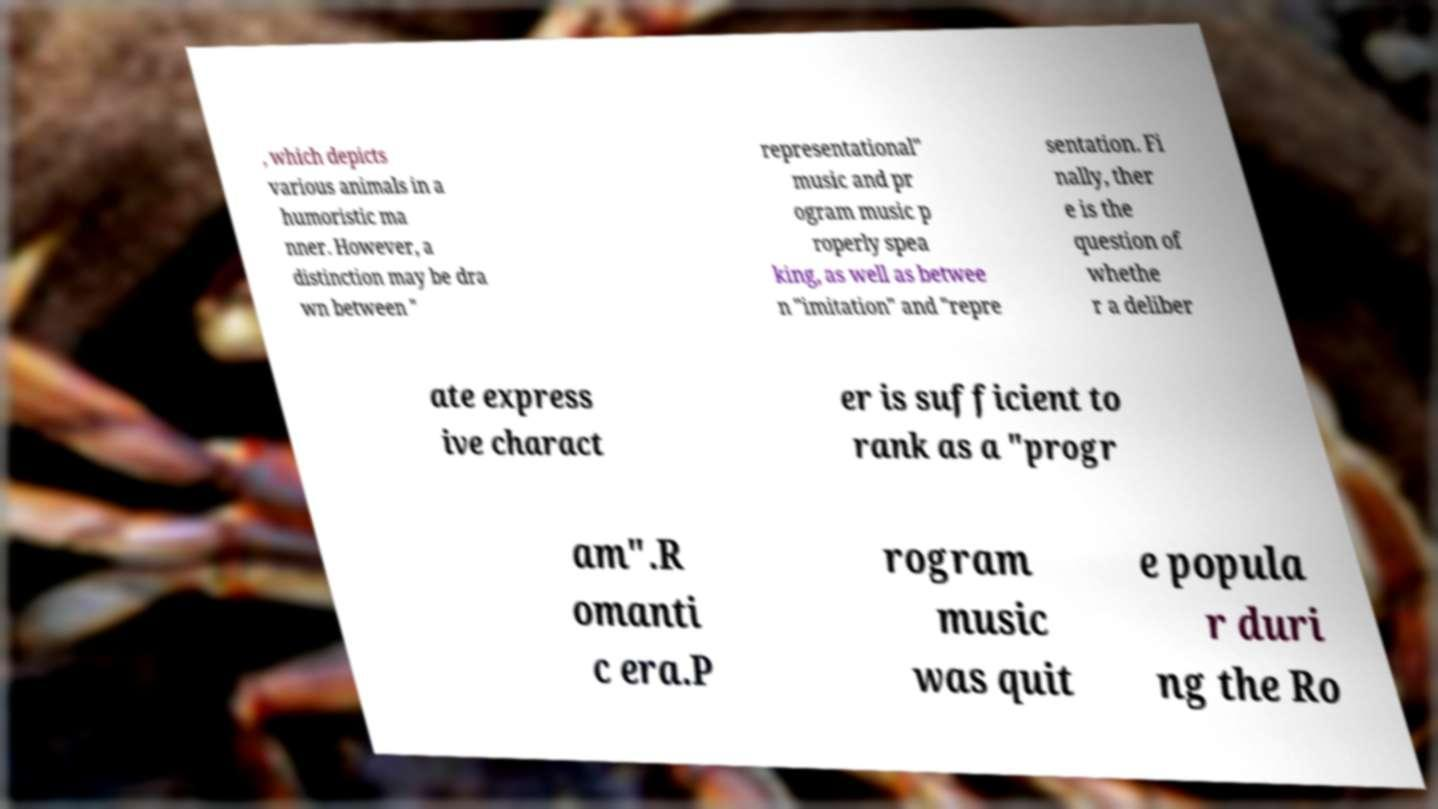Can you accurately transcribe the text from the provided image for me? , which depicts various animals in a humoristic ma nner. However, a distinction may be dra wn between " representational" music and pr ogram music p roperly spea king, as well as betwee n "imitation" and "repre sentation. Fi nally, ther e is the question of whethe r a deliber ate express ive charact er is sufficient to rank as a "progr am".R omanti c era.P rogram music was quit e popula r duri ng the Ro 